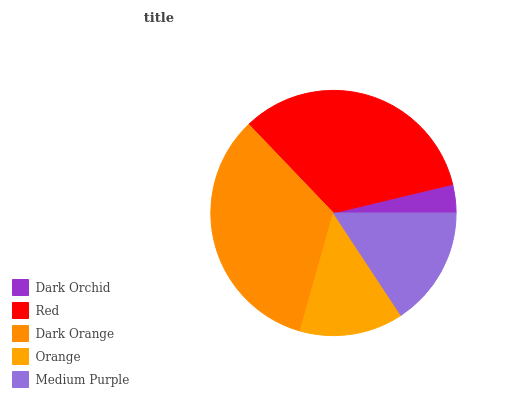Is Dark Orchid the minimum?
Answer yes or no. Yes. Is Dark Orange the maximum?
Answer yes or no. Yes. Is Red the minimum?
Answer yes or no. No. Is Red the maximum?
Answer yes or no. No. Is Red greater than Dark Orchid?
Answer yes or no. Yes. Is Dark Orchid less than Red?
Answer yes or no. Yes. Is Dark Orchid greater than Red?
Answer yes or no. No. Is Red less than Dark Orchid?
Answer yes or no. No. Is Medium Purple the high median?
Answer yes or no. Yes. Is Medium Purple the low median?
Answer yes or no. Yes. Is Dark Orange the high median?
Answer yes or no. No. Is Dark Orchid the low median?
Answer yes or no. No. 